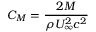<formula> <loc_0><loc_0><loc_500><loc_500>C _ { M } = \frac { 2 M } { \rho U _ { \infty } ^ { 2 } c ^ { 2 } }</formula> 